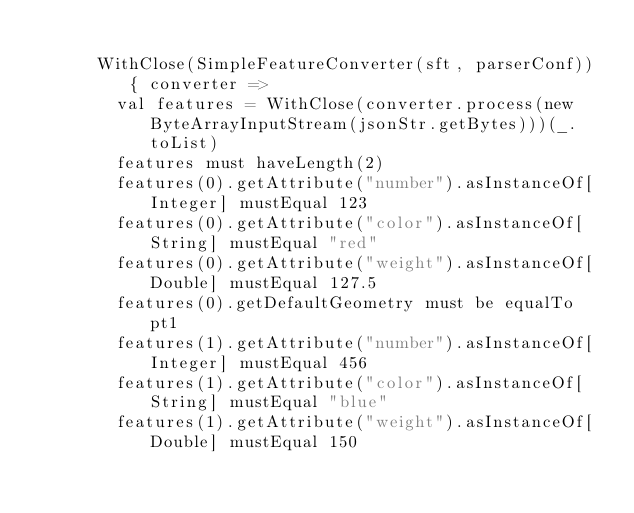Convert code to text. <code><loc_0><loc_0><loc_500><loc_500><_Scala_>
      WithClose(SimpleFeatureConverter(sft, parserConf)) { converter =>
        val features = WithClose(converter.process(new ByteArrayInputStream(jsonStr.getBytes)))(_.toList)
        features must haveLength(2)
        features(0).getAttribute("number").asInstanceOf[Integer] mustEqual 123
        features(0).getAttribute("color").asInstanceOf[String] mustEqual "red"
        features(0).getAttribute("weight").asInstanceOf[Double] mustEqual 127.5
        features(0).getDefaultGeometry must be equalTo pt1
        features(1).getAttribute("number").asInstanceOf[Integer] mustEqual 456
        features(1).getAttribute("color").asInstanceOf[String] mustEqual "blue"
        features(1).getAttribute("weight").asInstanceOf[Double] mustEqual 150</code> 